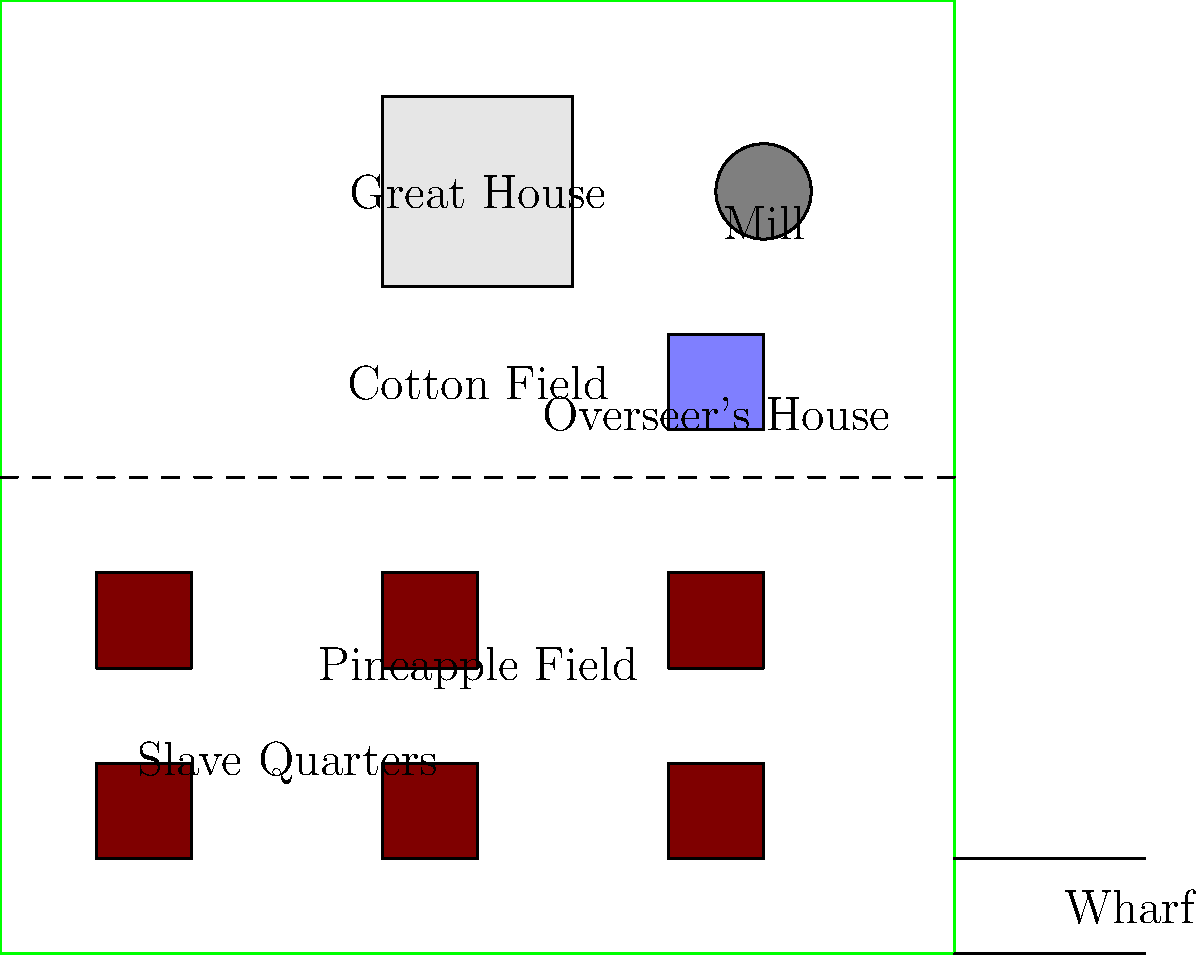In the diagram of a typical Bahamian plantation during the colonial era, what structure is located closest to the Great House and why was it positioned there? To answer this question, let's analyze the layout of the plantation:

1. The Great House is located in the upper center of the plantation, symbolizing the planter's authority and wealth.

2. Surrounding the Great House, we can identify several key structures:
   a) Slave quarters: Located in the lower left quadrant
   b) Fields: Divided into cotton and pineapple fields
   c) Mill: Located in the upper right corner
   d) Overseer's house: Positioned between the Great House and the mill

3. Among these structures, the overseer's house is closest to the Great House.

4. The overseer's house was strategically positioned for several reasons:
   a) Proximity to the Great House allowed for quick communication between the planter and the overseer.
   b) It provided a clear view of the plantation, including the fields and slave quarters.
   c) The location demonstrated the overseer's higher status compared to the enslaved people.
   d) It allowed the overseer to quickly respond to any issues on the plantation.

5. This positioning reflects the hierarchical nature of plantation society, with the planter at the top, the overseer as a middle manager, and the enslaved people at the bottom.
Answer: The overseer's house, positioned for efficient management and surveillance. 